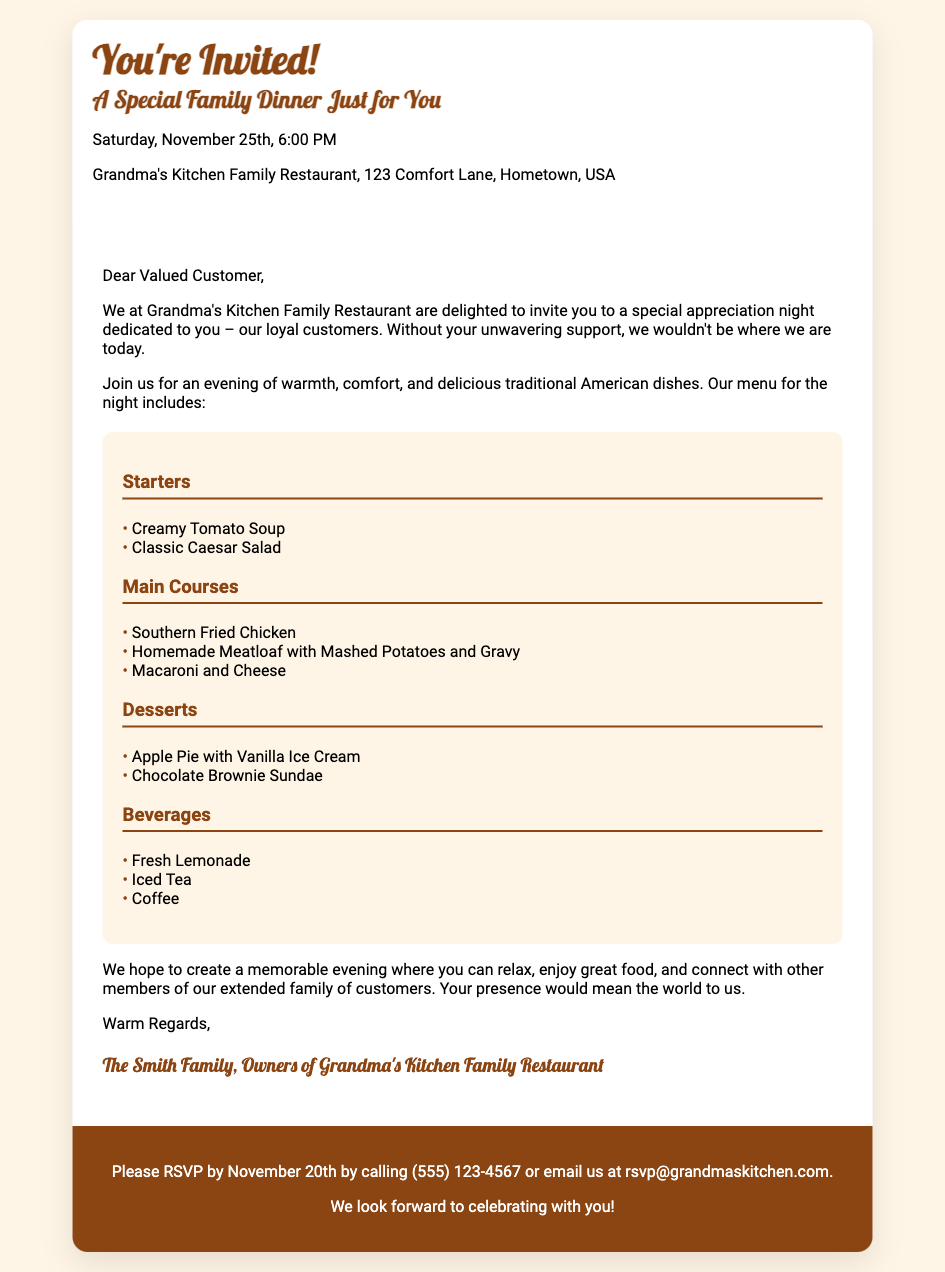What is the date of the special dinner? The date of the special dinner is mentioned in the document as Saturday, November 25th.
Answer: November 25th Where is Grandma's Kitchen Family Restaurant located? The location of Grandma's Kitchen Family Restaurant is provided as 123 Comfort Lane, Hometown, USA.
Answer: 123 Comfort Lane, Hometown, USA What are the two starters listed on the menu? The menu includes Creamy Tomato Soup and Classic Caesar Salad as starters.
Answer: Creamy Tomato Soup, Classic Caesar Salad How many main courses are featured in the dinner? There are three main courses listed in the menu: Southern Fried Chicken, Homemade Meatloaf with Mashed Potatoes and Gravy, and Macaroni and Cheese.
Answer: Three What is the RSVP deadline? The RSVP deadline is stated in the document as November 20th.
Answer: November 20th What is the purpose of this special dinner invitation? The purpose is to appreciate loyal customers for their support as mentioned in the invitation.
Answer: Appreciate loyal customers Who are the owners of Grandma's Kitchen Family Restaurant? The signature at the end of the document indicates that the owners are The Smith Family.
Answer: The Smith Family What type of food is being served at the special dinner? The type of food being served is traditional American dishes as described in the invitation.
Answer: Traditional American dishes 